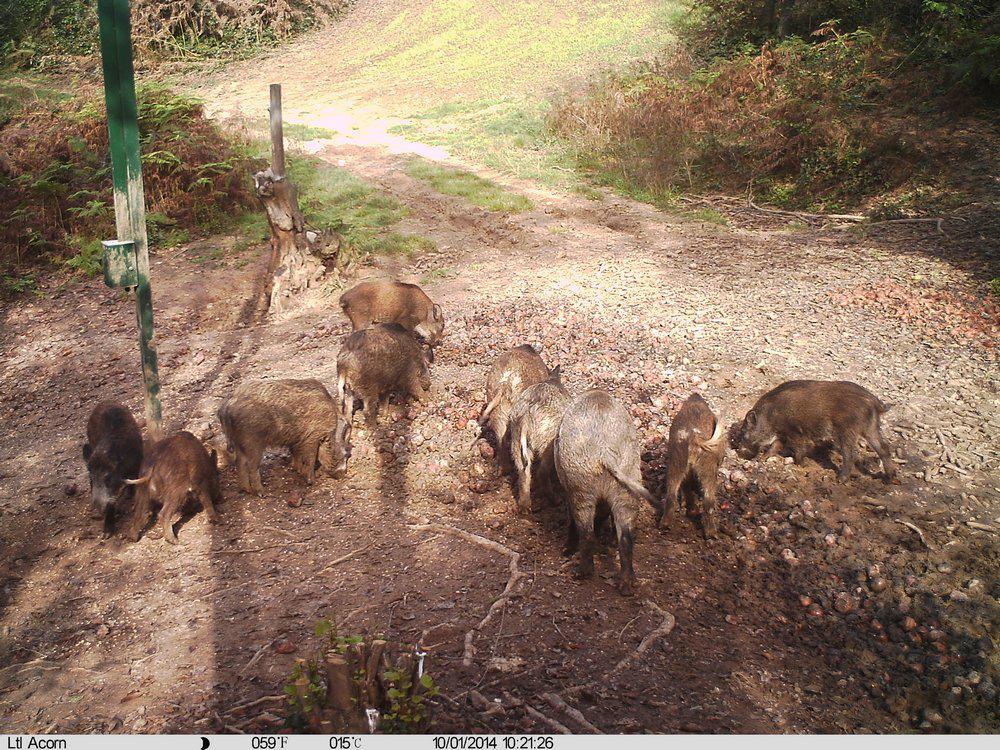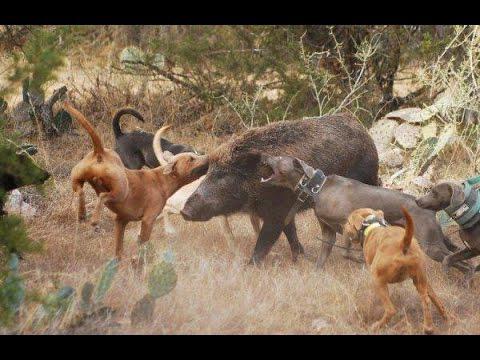The first image is the image on the left, the second image is the image on the right. For the images shown, is this caption "A mother warhog is rooting with her nose to the ground with her piglets near her" true? Answer yes or no. No. The first image is the image on the left, the second image is the image on the right. Examine the images to the left and right. Is the description "In the right image, there's a wild boar with her piglets." accurate? Answer yes or no. No. 